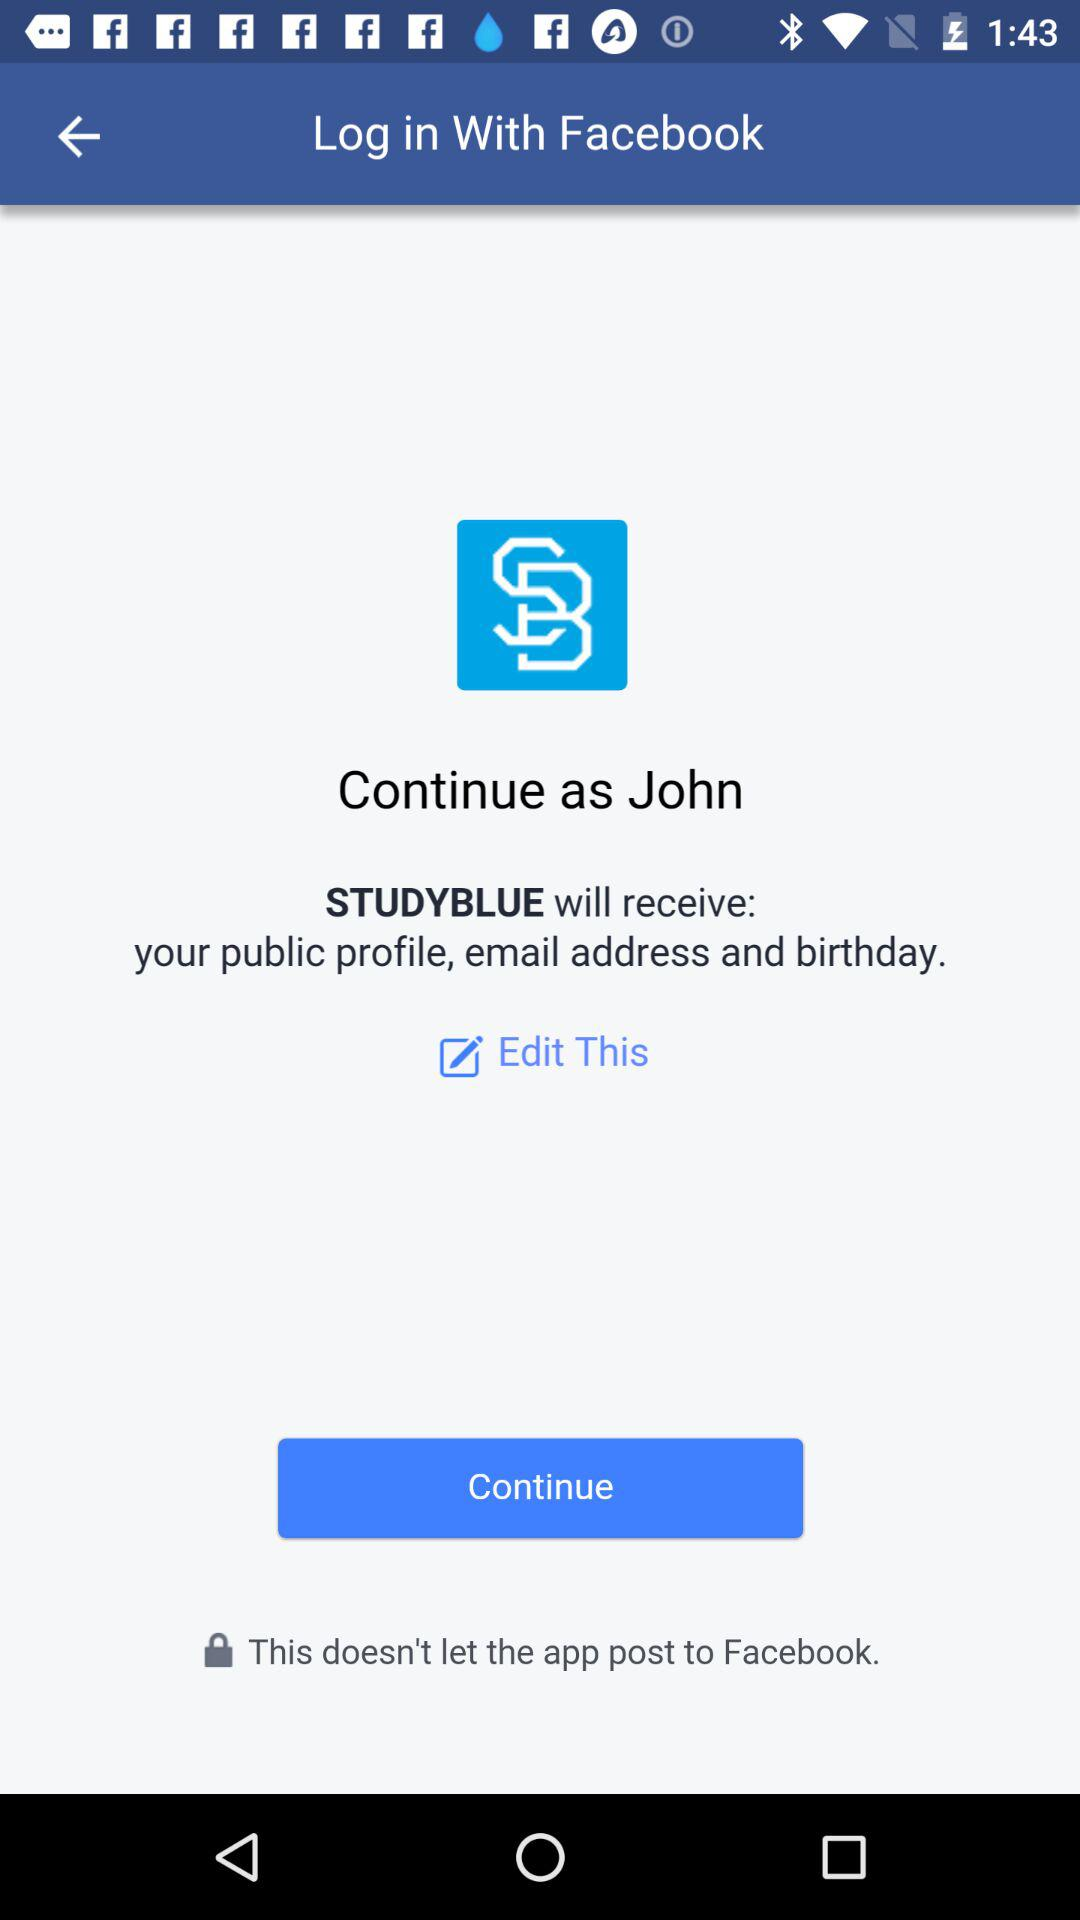How many profile details will STUDYBLUE receive?
Answer the question using a single word or phrase. 3 